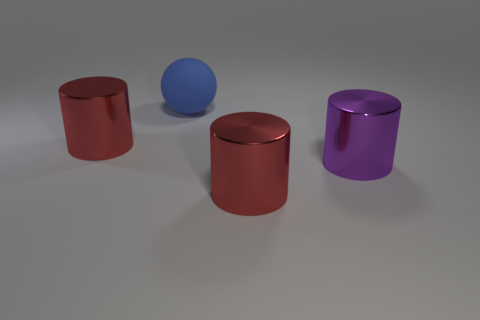Subtract all purple cylinders. How many cylinders are left? 2 Subtract all green spheres. How many red cylinders are left? 2 Subtract all red cylinders. How many cylinders are left? 1 Add 1 large blue spheres. How many objects exist? 5 Subtract all green cylinders. Subtract all brown blocks. How many cylinders are left? 3 Subtract all cylinders. How many objects are left? 1 Subtract all large gray matte objects. Subtract all purple shiny cylinders. How many objects are left? 3 Add 1 red shiny objects. How many red shiny objects are left? 3 Add 1 big blue objects. How many big blue objects exist? 2 Subtract 1 blue spheres. How many objects are left? 3 